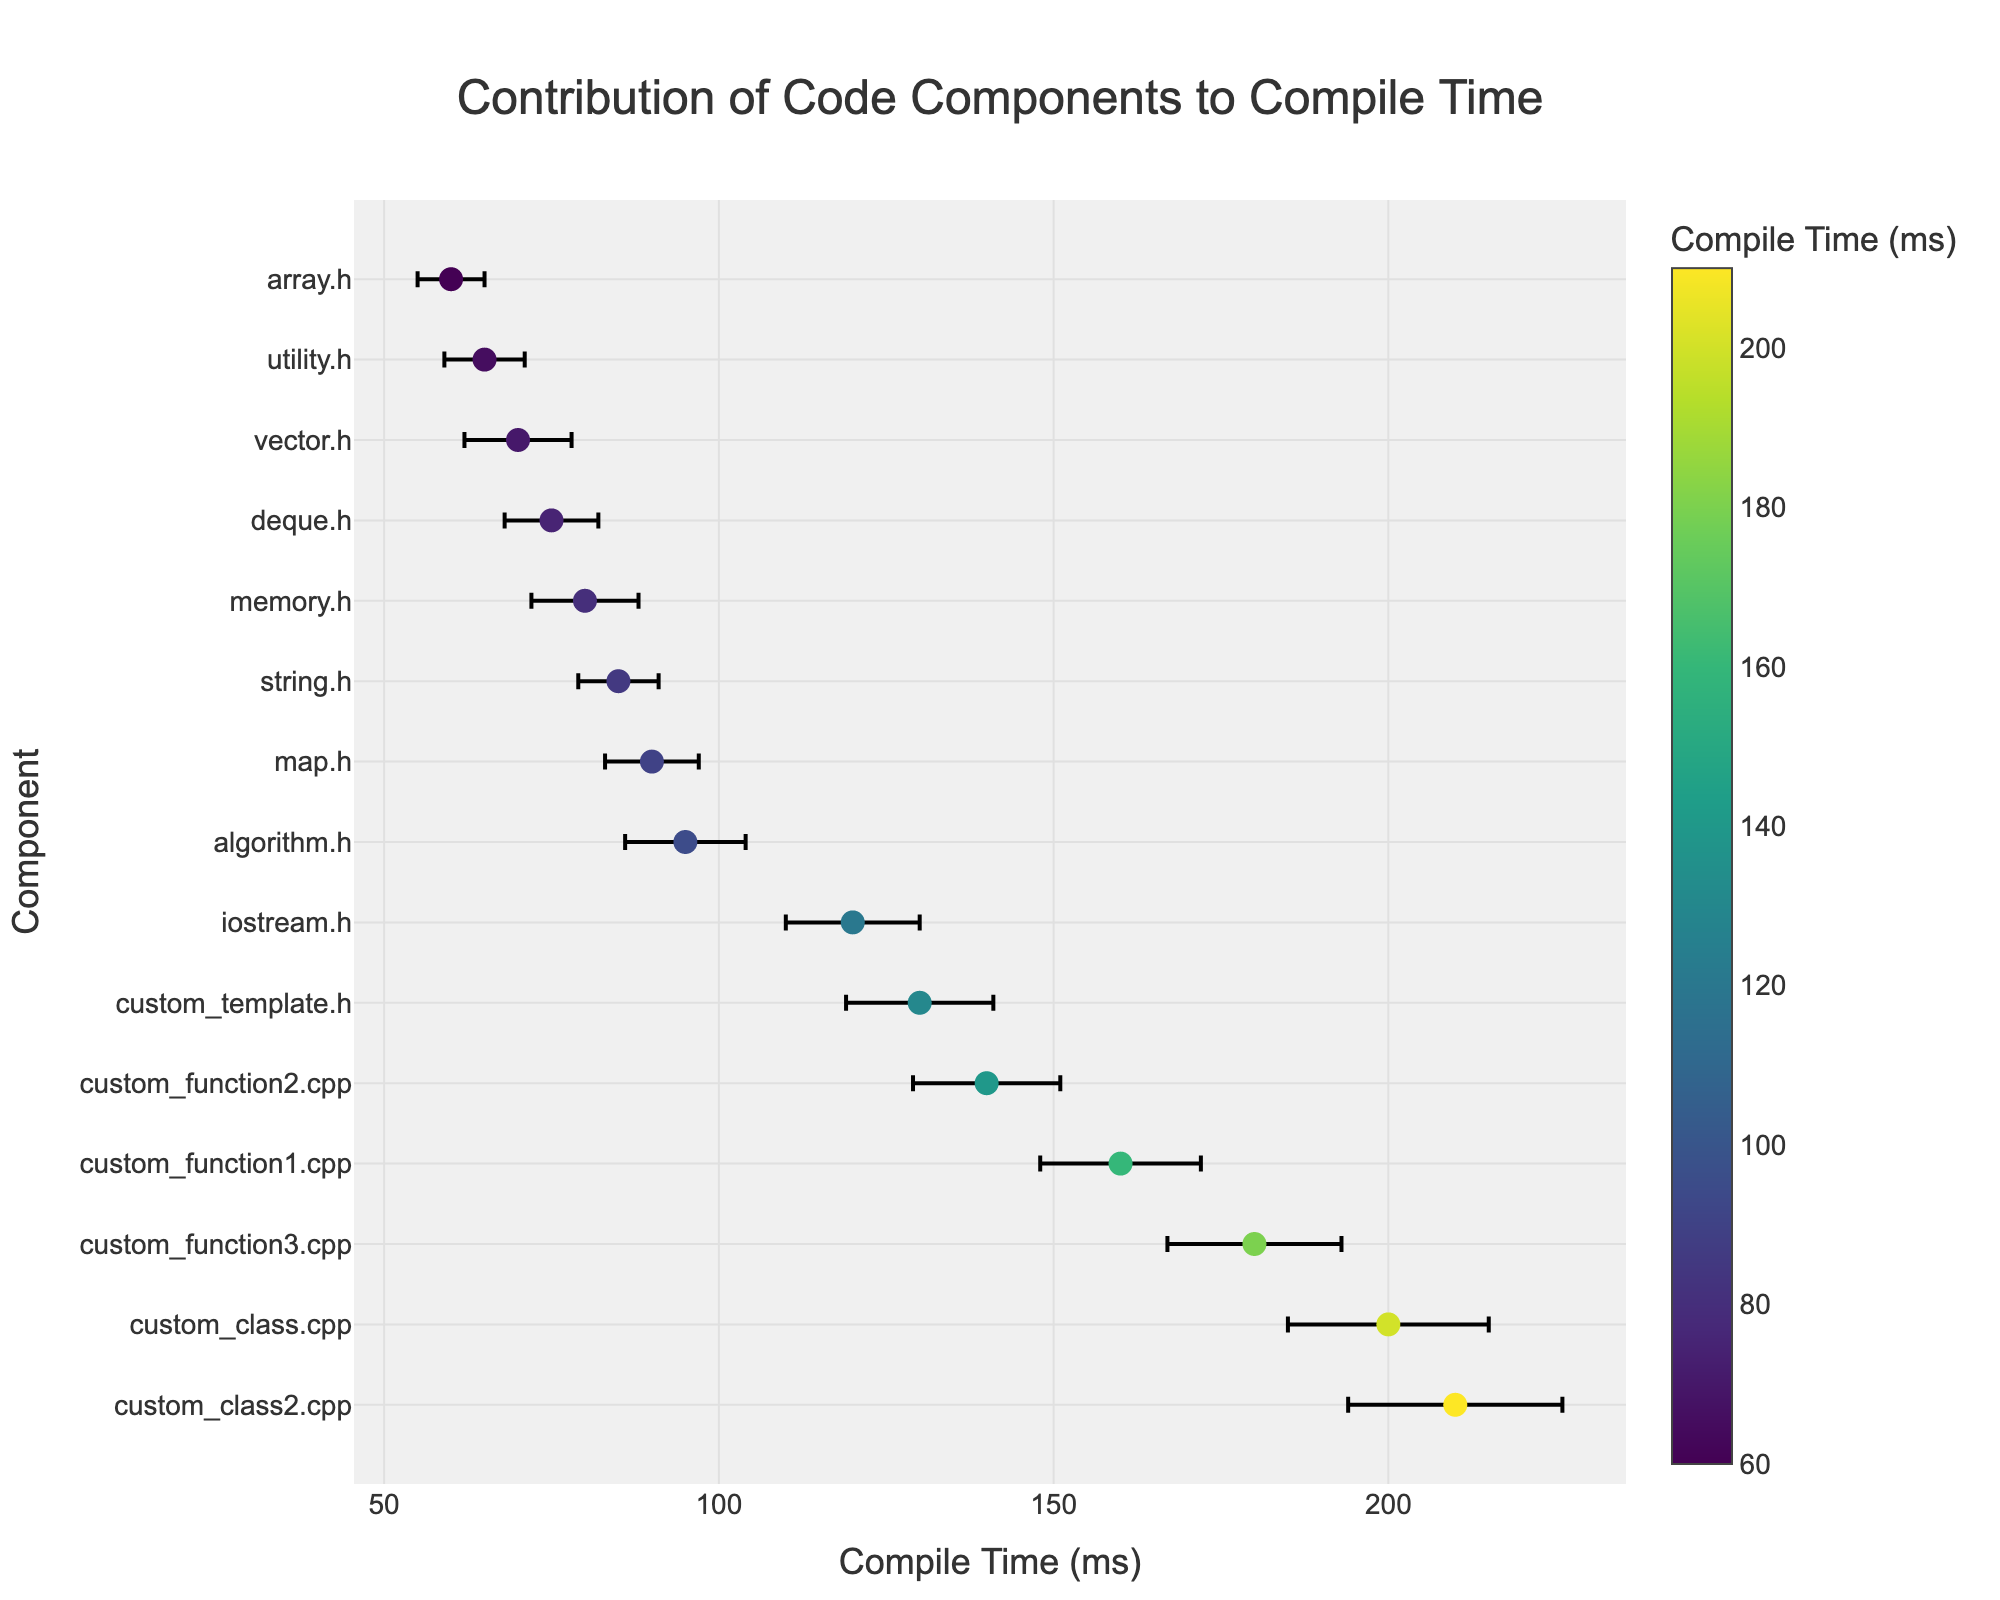what is the title of the plot? The title of the plot is located at the top center of the figure.
Answer: Contribution of Code Components to Compile Time how many components are represented in the plot? Each unique data point corresponds to a different component. Count the number of different components on the y-axis.
Answer: 15 which component has the highest compile time? The highest compile time is the point farthest to the right on the x-axis. Identify the corresponding y-axis label.
Answer: custom_class2.cpp what is the compile time and margin of error for iostream.h? Locate the data point for iostream.h on the y-axis and refer to its x-axis position and error bar length.
Answer: 120 ms, 10 ms which component has the smallest margin of error? The data point with the shortest error bar represents the smallest margin of error.
Answer: array.h what is the average compile time for custom functions (custom_function1.cpp, custom_function2.cpp and custom_function3.cpp)? Compile times are 160 ms, 140 ms, and 180 ms respectively. Compute the average: (160 + 140 + 180) / 3 = 160 ms
Answer: 160 ms compare the compile times of vector.h and deque.h. which one is larger and by how much? Vector.h and deque.h compile times are 70 ms and 75 ms respectively. The difference is 75 - 70 = 5 ms.
Answer: deque.h by 5 ms is the compile time of string.h within the margin of error range of vector.h? String.h has a compile time of 85 ms. Vector.h's compile time range with its margin of error is 70 ± 8 ms (62 ms to 78 ms). String.h is outside this range.
Answer: No which component has the widest margin of error and what is the value? The component with the longest error bar indicates the widest margin of error.
Answer: custom_class2.cpp, 16 ms 